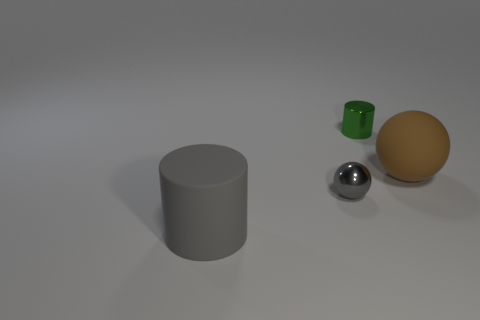Add 1 tiny brown rubber balls. How many objects exist? 5 Add 4 brown things. How many brown things are left? 5 Add 4 gray rubber cylinders. How many gray rubber cylinders exist? 5 Subtract 0 cyan balls. How many objects are left? 4 Subtract all small gray balls. Subtract all big brown objects. How many objects are left? 2 